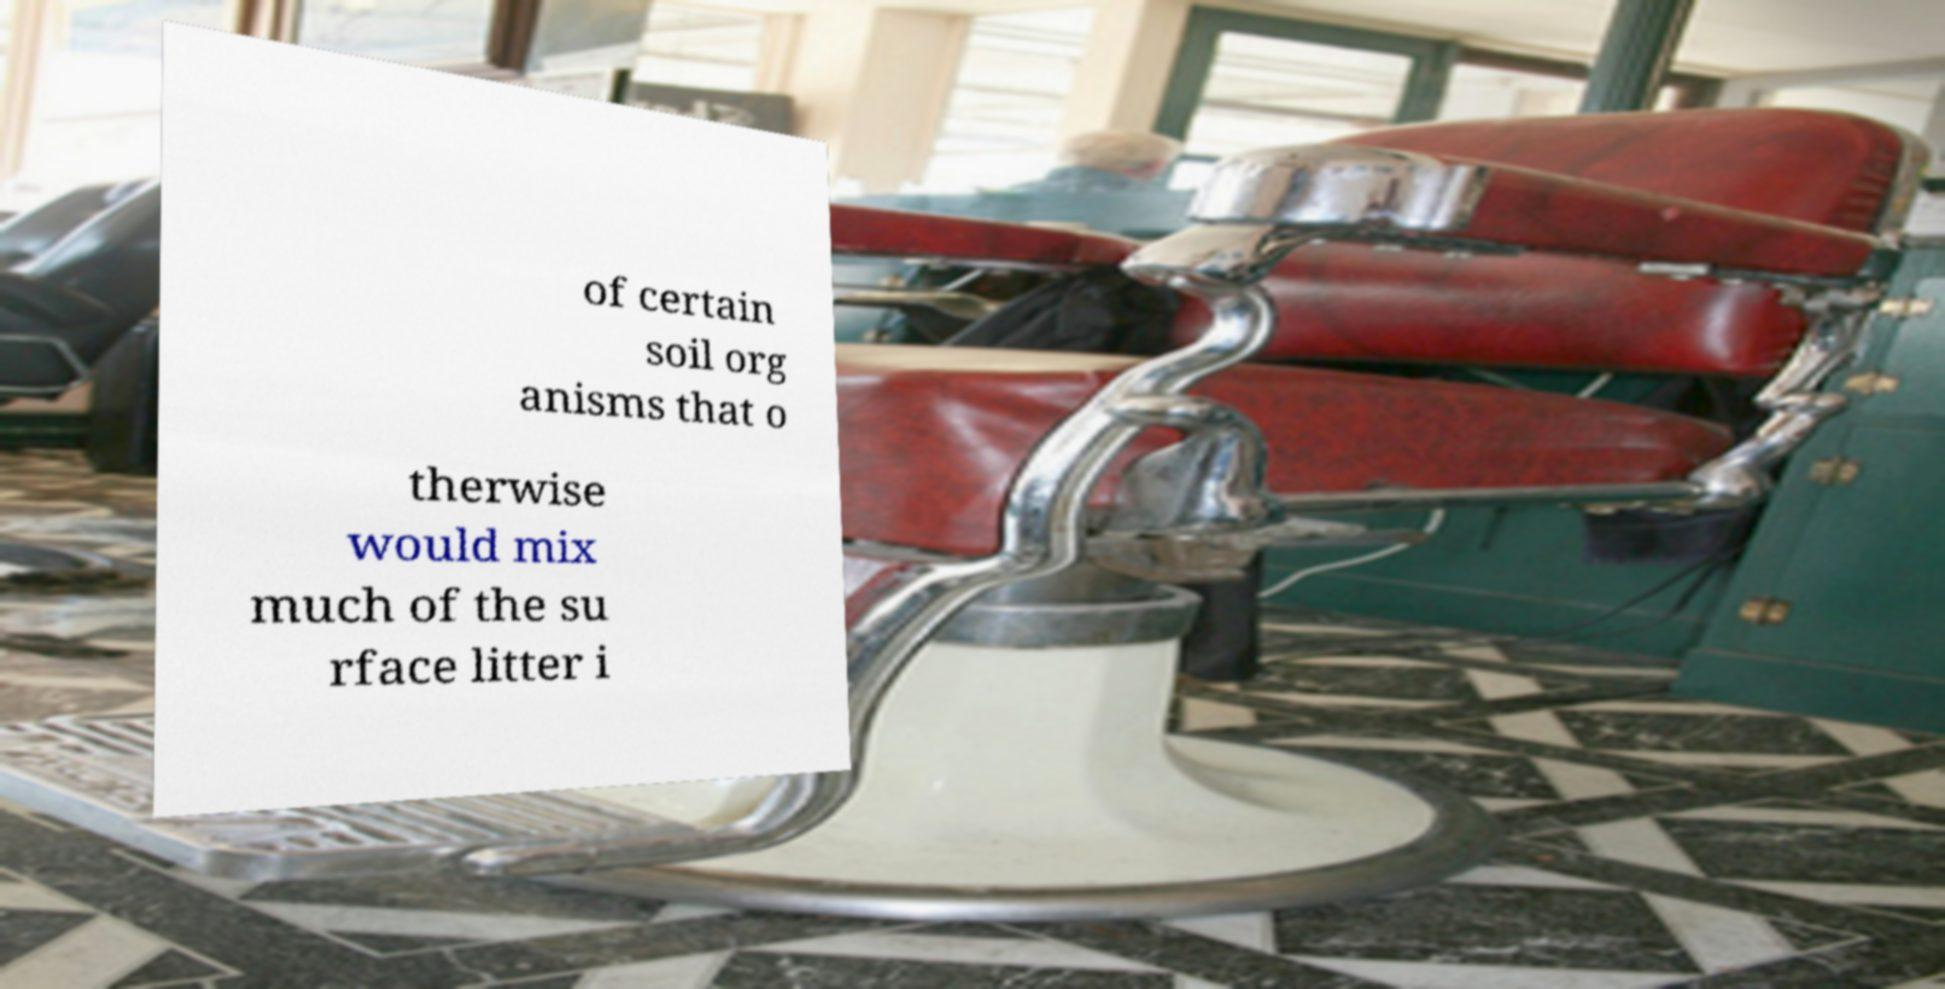Could you extract and type out the text from this image? of certain soil org anisms that o therwise would mix much of the su rface litter i 